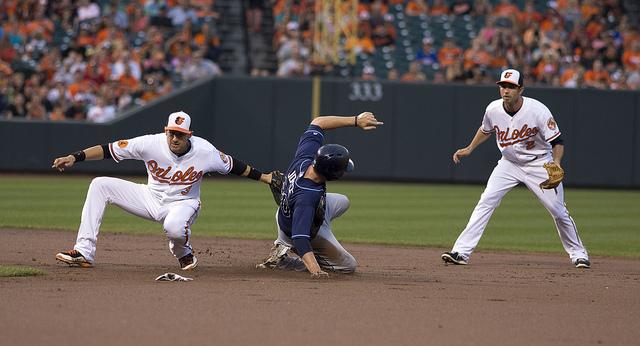Did one of the players fall?
Answer briefly. Yes. What team is sliding into base?
Write a very short answer. Rays. What color is his uniform?
Answer briefly. Blue. Is this game sold out?
Short answer required. No. How many players are playing?
Keep it brief. 3. Who is touching the man in the blue shirt?
Concise answer only. 1 baseman. Are all three of these players on the same team?
Short answer required. No. Is this runner on base?
Keep it brief. No. 